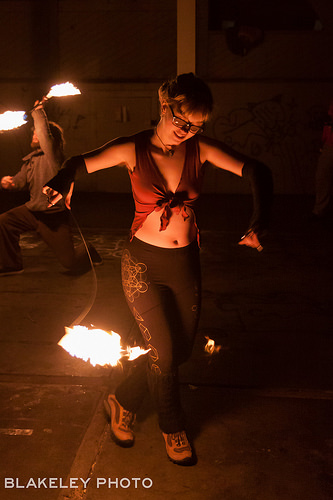<image>
Is there a column to the left of the girl? No. The column is not to the left of the girl. From this viewpoint, they have a different horizontal relationship. 